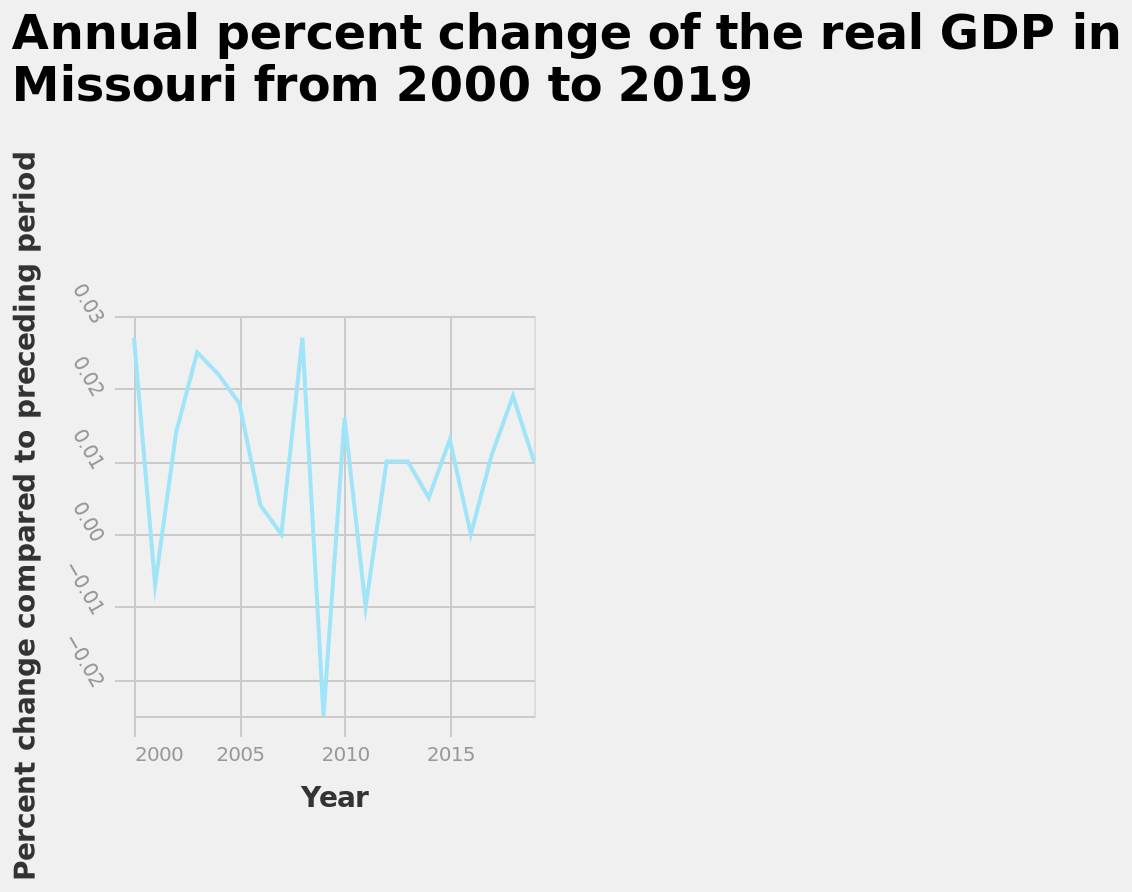<image>
What is the overall trend of the annual percent change in Missouri's real GDP from 2000 to 2019? The overall trend of the line chart shows the changes in the annual percent growth rate of Missouri's real GDP from 2000 to 2019. Is there a clear pattern in the changes of GDP?  No, the GDP changes regularly without a clear pattern. 